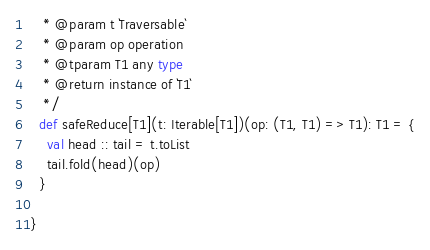<code> <loc_0><loc_0><loc_500><loc_500><_Scala_>   * @param t `Traversable`
   * @param op operation
   * @tparam T1 any type
   * @return instance of `T1`
   */
  def safeReduce[T1](t: Iterable[T1])(op: (T1, T1) => T1): T1 = {
    val head :: tail = t.toList
    tail.fold(head)(op)
  }

}
</code> 